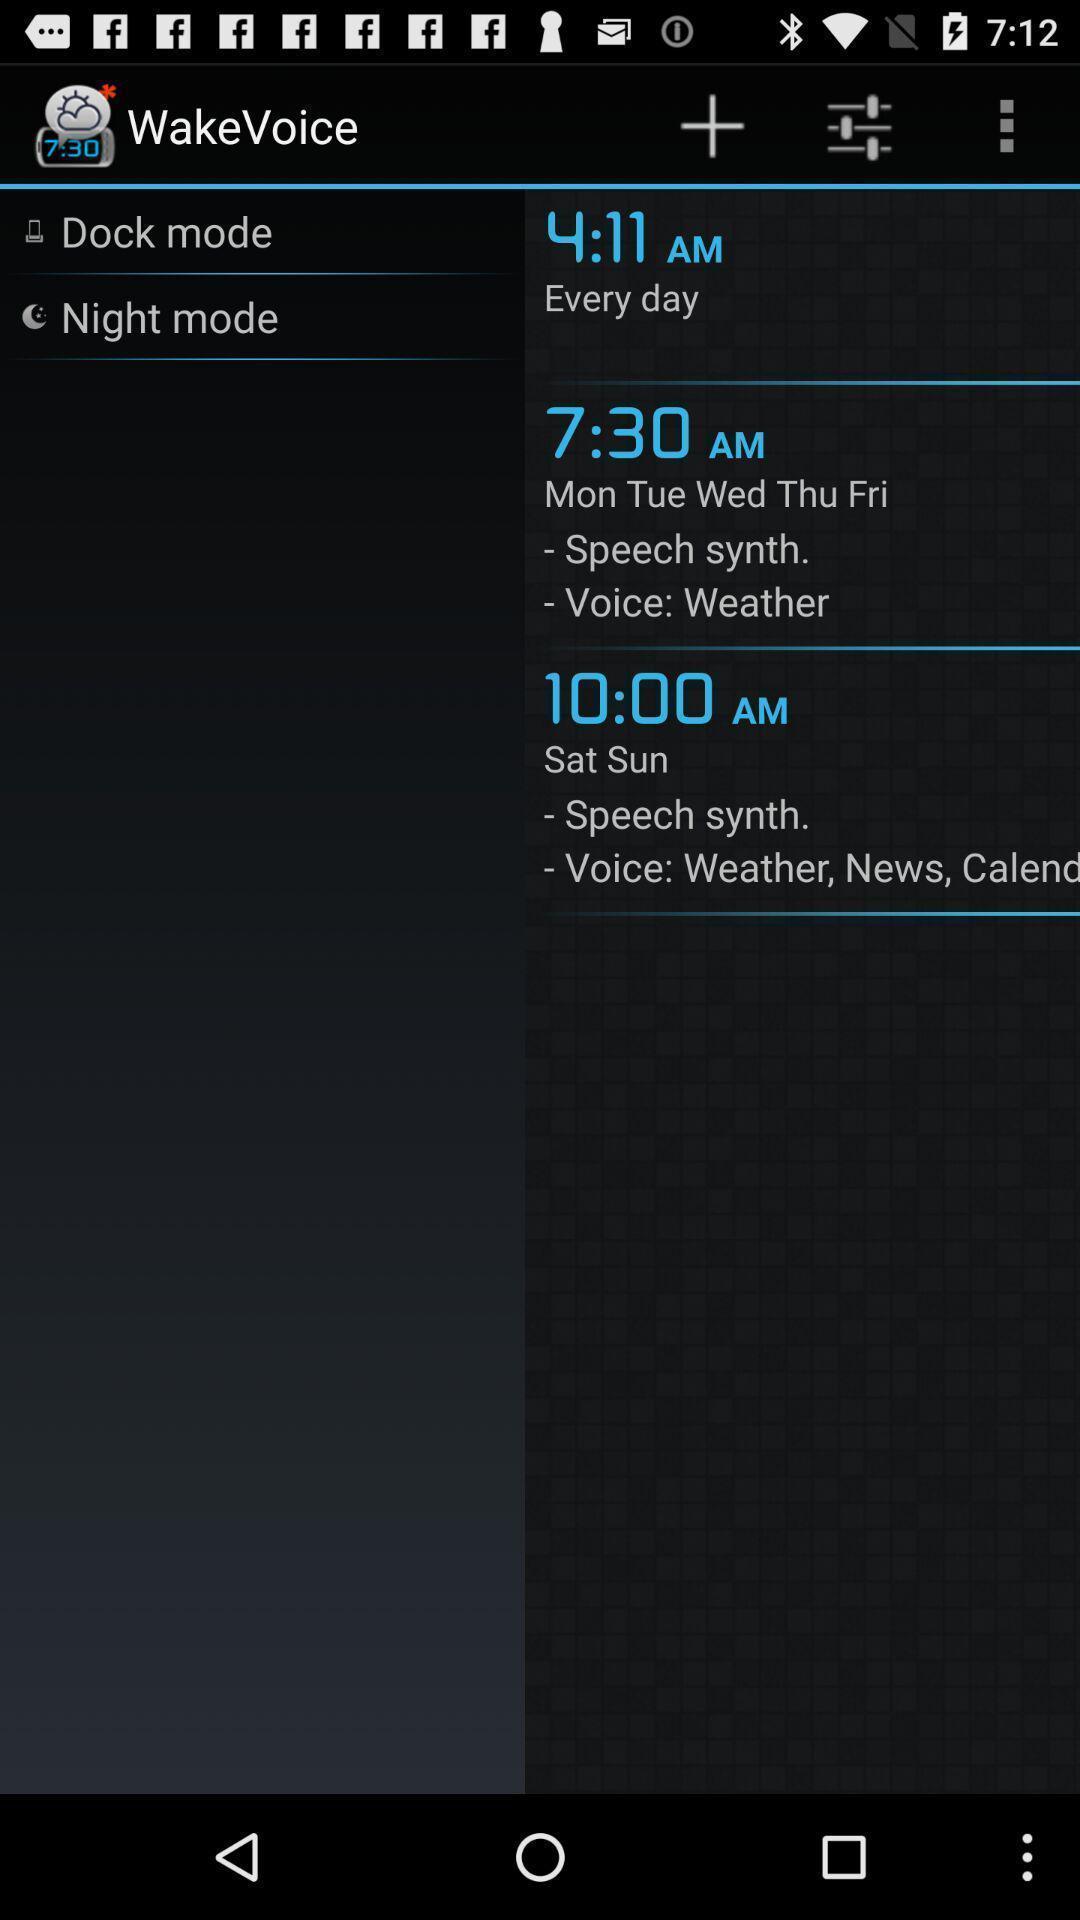Give me a summary of this screen capture. Screen page of list of timings in a alarm app. 